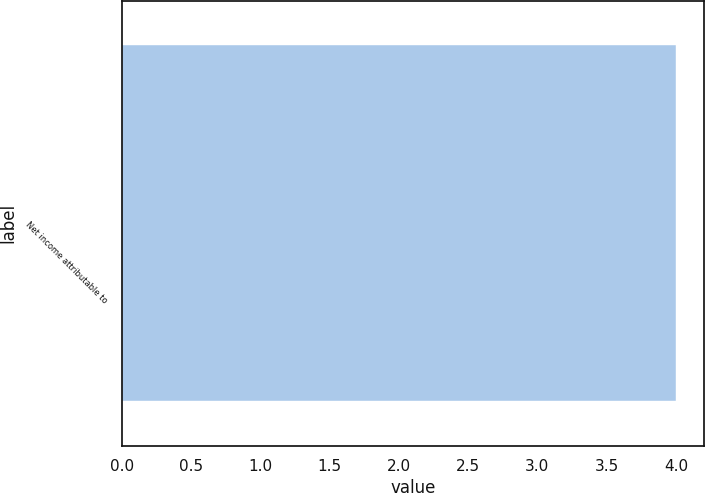Convert chart. <chart><loc_0><loc_0><loc_500><loc_500><bar_chart><fcel>Net income attributable to<nl><fcel>4<nl></chart> 